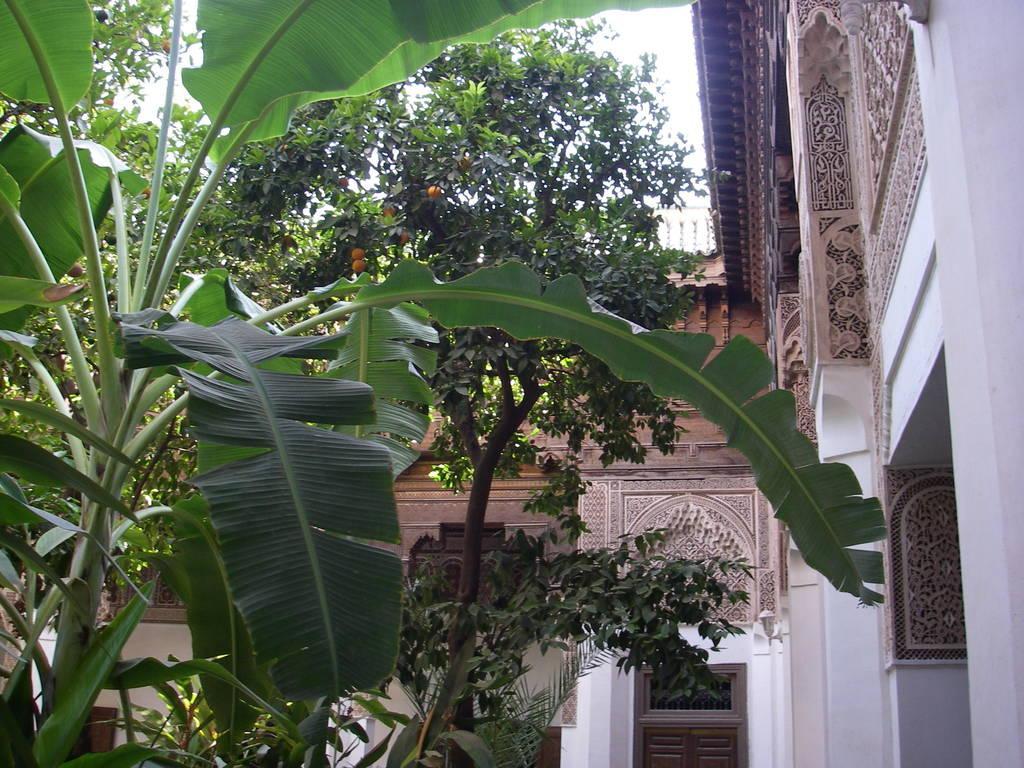Can you describe this image briefly? On the left side it is a banana plant, in the middle it is an orange plant, there are oranges in it. On the right side it's a monument. 